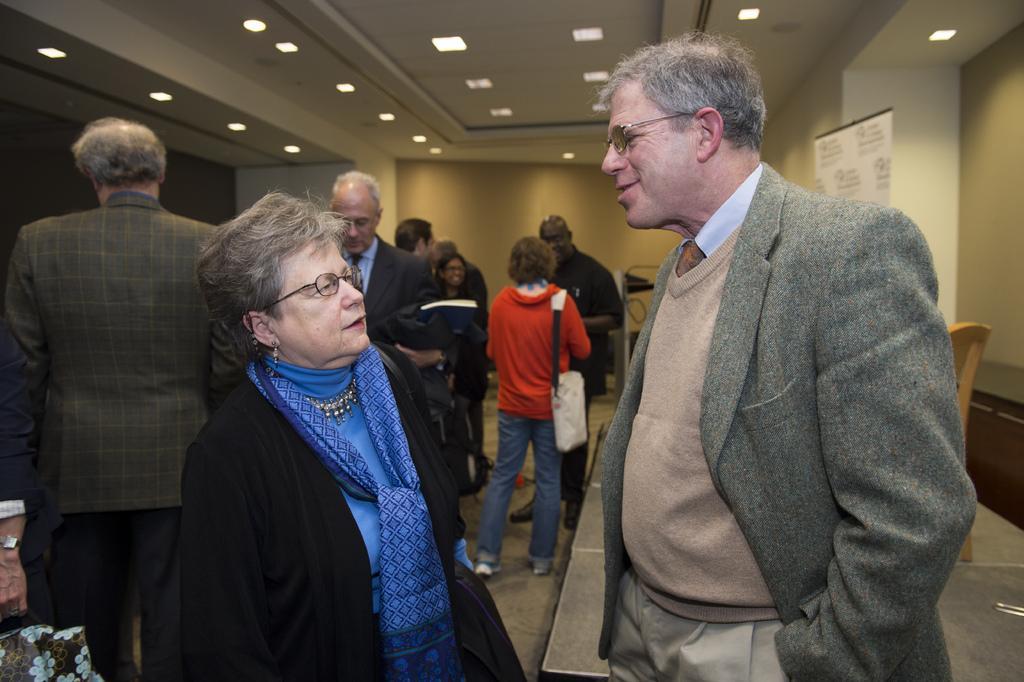Please provide a concise description of this image. In this image we can see a few people standing on the floor. In the background we can see the wall and also a banner. At the top there is ceiling with the ceiling lights. 